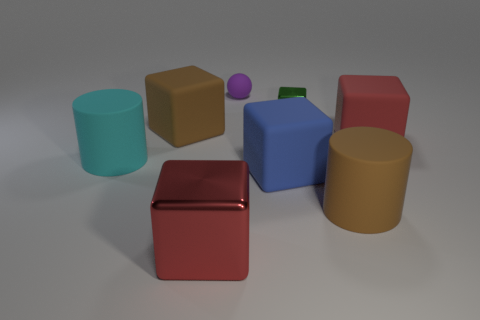Subtract all big blue rubber cubes. How many cubes are left? 4 Subtract all brown blocks. How many blocks are left? 4 Subtract all gray cubes. Subtract all red cylinders. How many cubes are left? 5 Add 1 large rubber blocks. How many objects exist? 9 Subtract all spheres. How many objects are left? 7 Add 4 small green matte spheres. How many small green matte spheres exist? 4 Subtract 0 brown spheres. How many objects are left? 8 Subtract all big cylinders. Subtract all rubber cylinders. How many objects are left? 4 Add 2 metallic objects. How many metallic objects are left? 4 